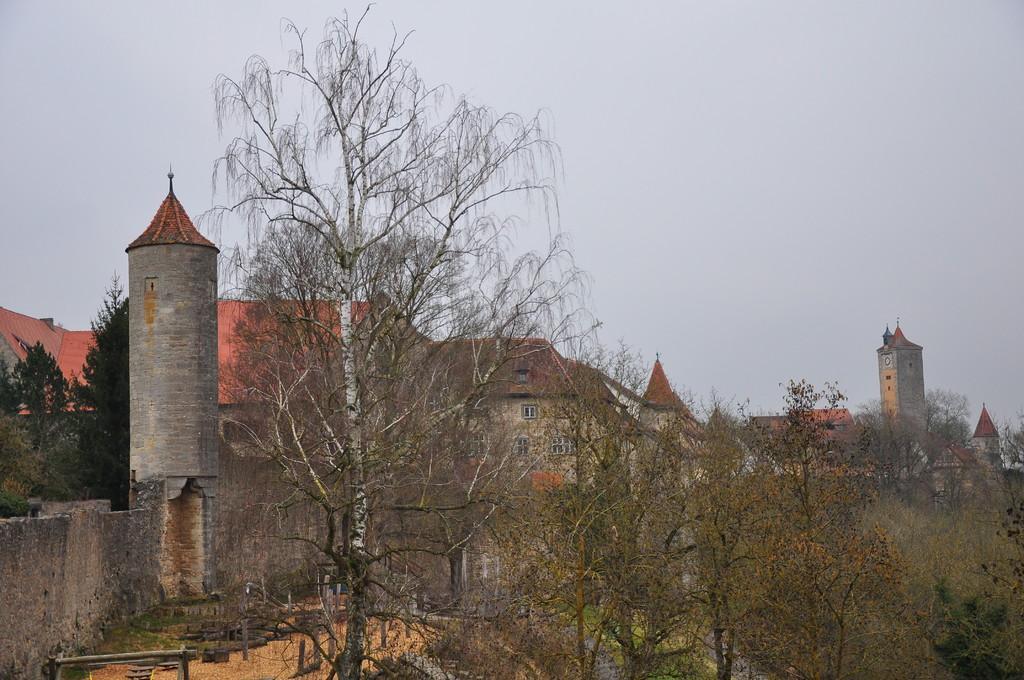How would you summarize this image in a sentence or two? In this image we can see some houses, windows, there are some trees, wooden sticks, also we can see the sky. 